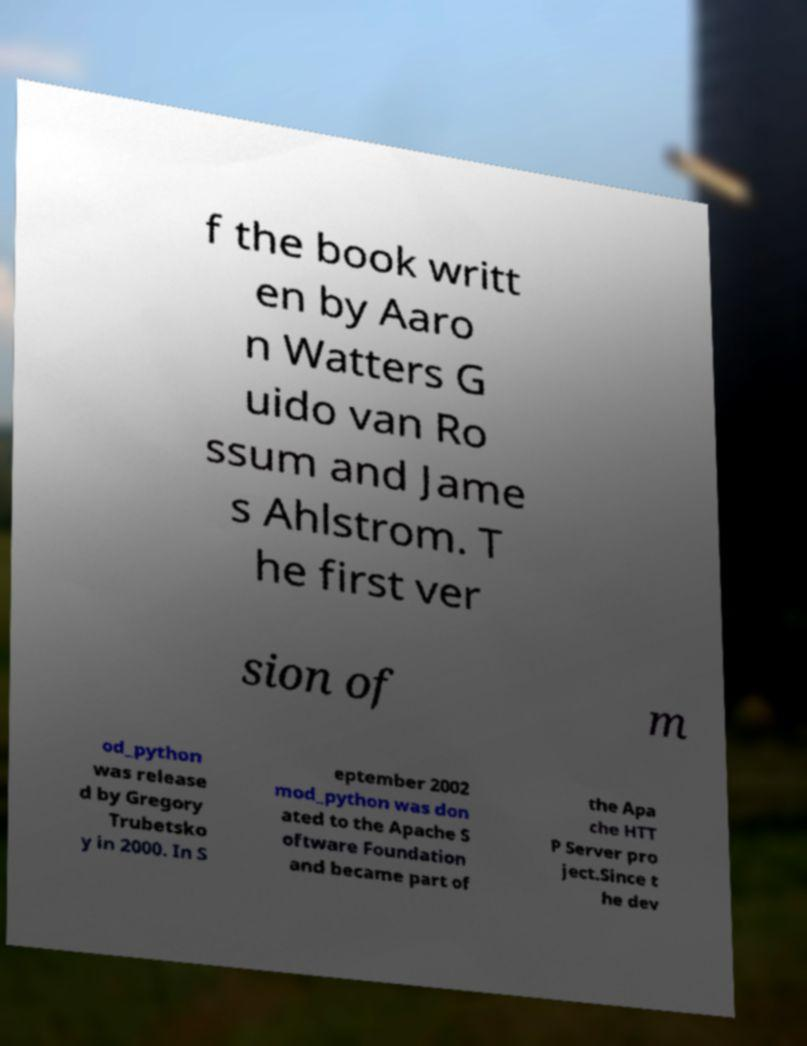Can you accurately transcribe the text from the provided image for me? f the book writt en by Aaro n Watters G uido van Ro ssum and Jame s Ahlstrom. T he first ver sion of m od_python was release d by Gregory Trubetsko y in 2000. In S eptember 2002 mod_python was don ated to the Apache S oftware Foundation and became part of the Apa che HTT P Server pro ject.Since t he dev 